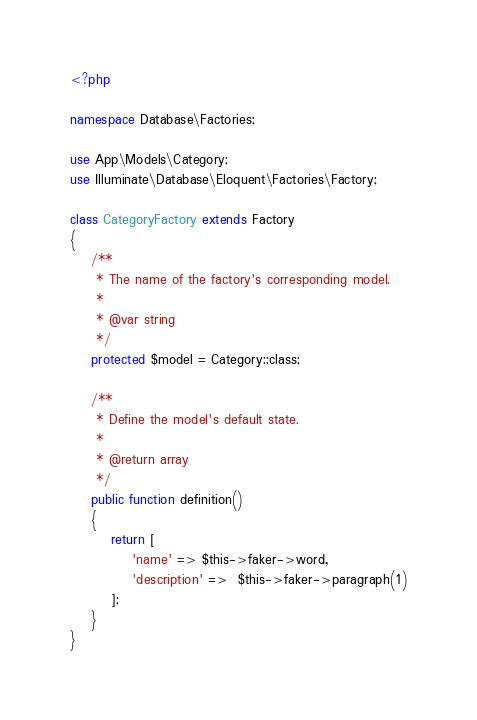<code> <loc_0><loc_0><loc_500><loc_500><_PHP_><?php

namespace Database\Factories;

use App\Models\Category;
use Illuminate\Database\Eloquent\Factories\Factory;

class CategoryFactory extends Factory
{
    /**
     * The name of the factory's corresponding model.
     *
     * @var string
     */
    protected $model = Category::class;

    /**
     * Define the model's default state.
     *
     * @return array
     */
    public function definition()
    {
        return [
            'name' => $this->faker->word,
            'description' =>  $this->faker->paragraph(1)
        ];
    }
}
</code> 